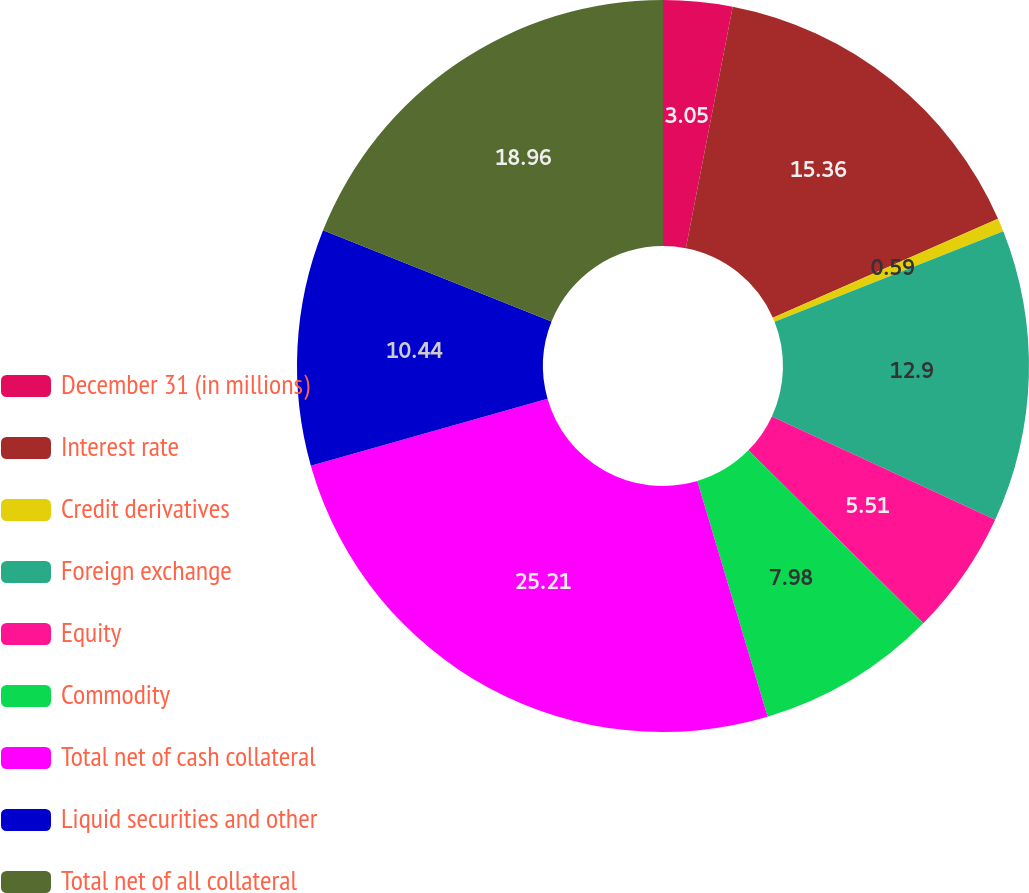<chart> <loc_0><loc_0><loc_500><loc_500><pie_chart><fcel>December 31 (in millions)<fcel>Interest rate<fcel>Credit derivatives<fcel>Foreign exchange<fcel>Equity<fcel>Commodity<fcel>Total net of cash collateral<fcel>Liquid securities and other<fcel>Total net of all collateral<nl><fcel>3.05%<fcel>15.36%<fcel>0.59%<fcel>12.9%<fcel>5.51%<fcel>7.98%<fcel>25.22%<fcel>10.44%<fcel>18.96%<nl></chart> 